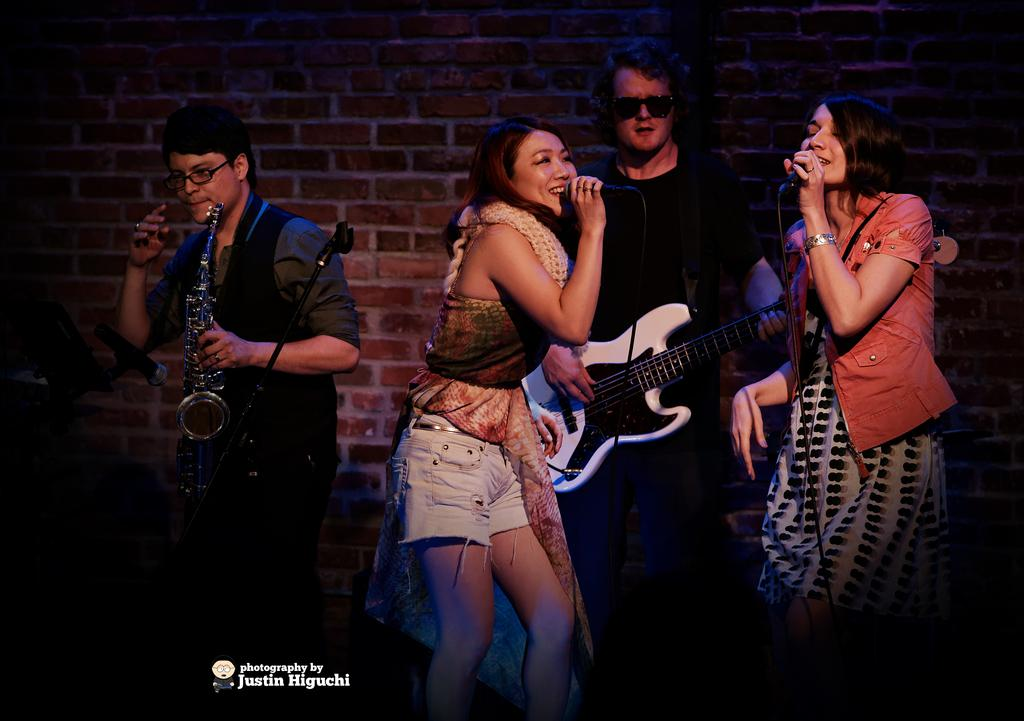What is happening in the image involving a group of people? There is a group of people in the image, with one person playing a musical instrument and another person singing a song. Where is the person playing the instrument located in the image? The person playing the instrument is on the left side of the image. Where is the person singing located in the image? The person singing is on the right side of the image. What type of farm animals can be seen in the image? There are no farm animals present in the image; it features a group of people with one person playing a musical instrument and another person singing a song. 